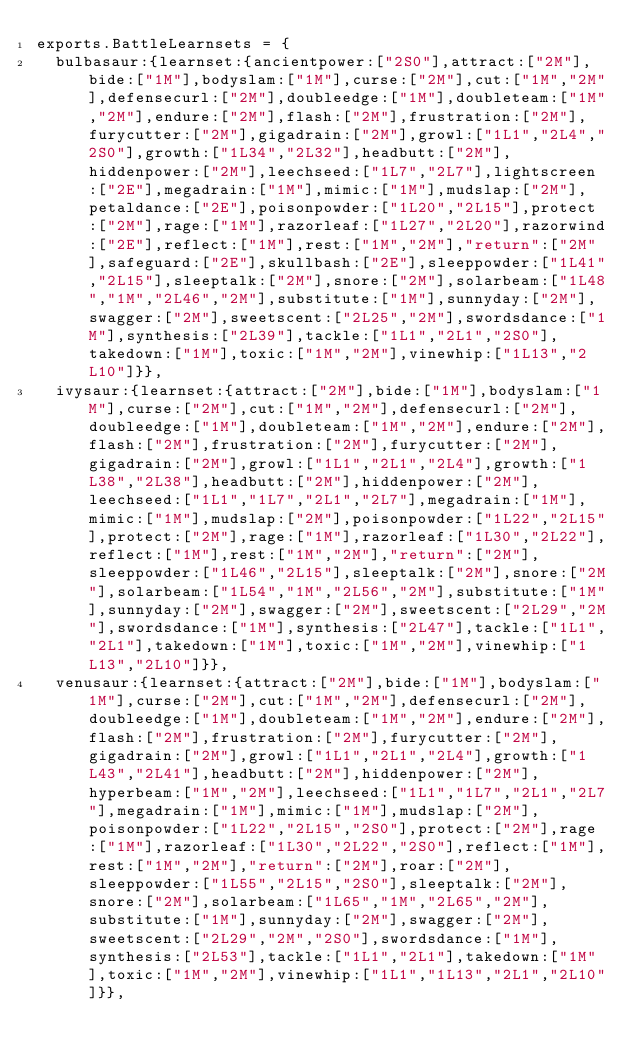Convert code to text. <code><loc_0><loc_0><loc_500><loc_500><_JavaScript_>exports.BattleLearnsets = {
	bulbasaur:{learnset:{ancientpower:["2S0"],attract:["2M"],bide:["1M"],bodyslam:["1M"],curse:["2M"],cut:["1M","2M"],defensecurl:["2M"],doubleedge:["1M"],doubleteam:["1M","2M"],endure:["2M"],flash:["2M"],frustration:["2M"],furycutter:["2M"],gigadrain:["2M"],growl:["1L1","2L4","2S0"],growth:["1L34","2L32"],headbutt:["2M"],hiddenpower:["2M"],leechseed:["1L7","2L7"],lightscreen:["2E"],megadrain:["1M"],mimic:["1M"],mudslap:["2M"],petaldance:["2E"],poisonpowder:["1L20","2L15"],protect:["2M"],rage:["1M"],razorleaf:["1L27","2L20"],razorwind:["2E"],reflect:["1M"],rest:["1M","2M"],"return":["2M"],safeguard:["2E"],skullbash:["2E"],sleeppowder:["1L41","2L15"],sleeptalk:["2M"],snore:["2M"],solarbeam:["1L48","1M","2L46","2M"],substitute:["1M"],sunnyday:["2M"],swagger:["2M"],sweetscent:["2L25","2M"],swordsdance:["1M"],synthesis:["2L39"],tackle:["1L1","2L1","2S0"],takedown:["1M"],toxic:["1M","2M"],vinewhip:["1L13","2L10"]}},
	ivysaur:{learnset:{attract:["2M"],bide:["1M"],bodyslam:["1M"],curse:["2M"],cut:["1M","2M"],defensecurl:["2M"],doubleedge:["1M"],doubleteam:["1M","2M"],endure:["2M"],flash:["2M"],frustration:["2M"],furycutter:["2M"],gigadrain:["2M"],growl:["1L1","2L1","2L4"],growth:["1L38","2L38"],headbutt:["2M"],hiddenpower:["2M"],leechseed:["1L1","1L7","2L1","2L7"],megadrain:["1M"],mimic:["1M"],mudslap:["2M"],poisonpowder:["1L22","2L15"],protect:["2M"],rage:["1M"],razorleaf:["1L30","2L22"],reflect:["1M"],rest:["1M","2M"],"return":["2M"],sleeppowder:["1L46","2L15"],sleeptalk:["2M"],snore:["2M"],solarbeam:["1L54","1M","2L56","2M"],substitute:["1M"],sunnyday:["2M"],swagger:["2M"],sweetscent:["2L29","2M"],swordsdance:["1M"],synthesis:["2L47"],tackle:["1L1","2L1"],takedown:["1M"],toxic:["1M","2M"],vinewhip:["1L13","2L10"]}},
	venusaur:{learnset:{attract:["2M"],bide:["1M"],bodyslam:["1M"],curse:["2M"],cut:["1M","2M"],defensecurl:["2M"],doubleedge:["1M"],doubleteam:["1M","2M"],endure:["2M"],flash:["2M"],frustration:["2M"],furycutter:["2M"],gigadrain:["2M"],growl:["1L1","2L1","2L4"],growth:["1L43","2L41"],headbutt:["2M"],hiddenpower:["2M"],hyperbeam:["1M","2M"],leechseed:["1L1","1L7","2L1","2L7"],megadrain:["1M"],mimic:["1M"],mudslap:["2M"],poisonpowder:["1L22","2L15","2S0"],protect:["2M"],rage:["1M"],razorleaf:["1L30","2L22","2S0"],reflect:["1M"],rest:["1M","2M"],"return":["2M"],roar:["2M"],sleeppowder:["1L55","2L15","2S0"],sleeptalk:["2M"],snore:["2M"],solarbeam:["1L65","1M","2L65","2M"],substitute:["1M"],sunnyday:["2M"],swagger:["2M"],sweetscent:["2L29","2M","2S0"],swordsdance:["1M"],synthesis:["2L53"],tackle:["1L1","2L1"],takedown:["1M"],toxic:["1M","2M"],vinewhip:["1L1","1L13","2L1","2L10"]}},</code> 